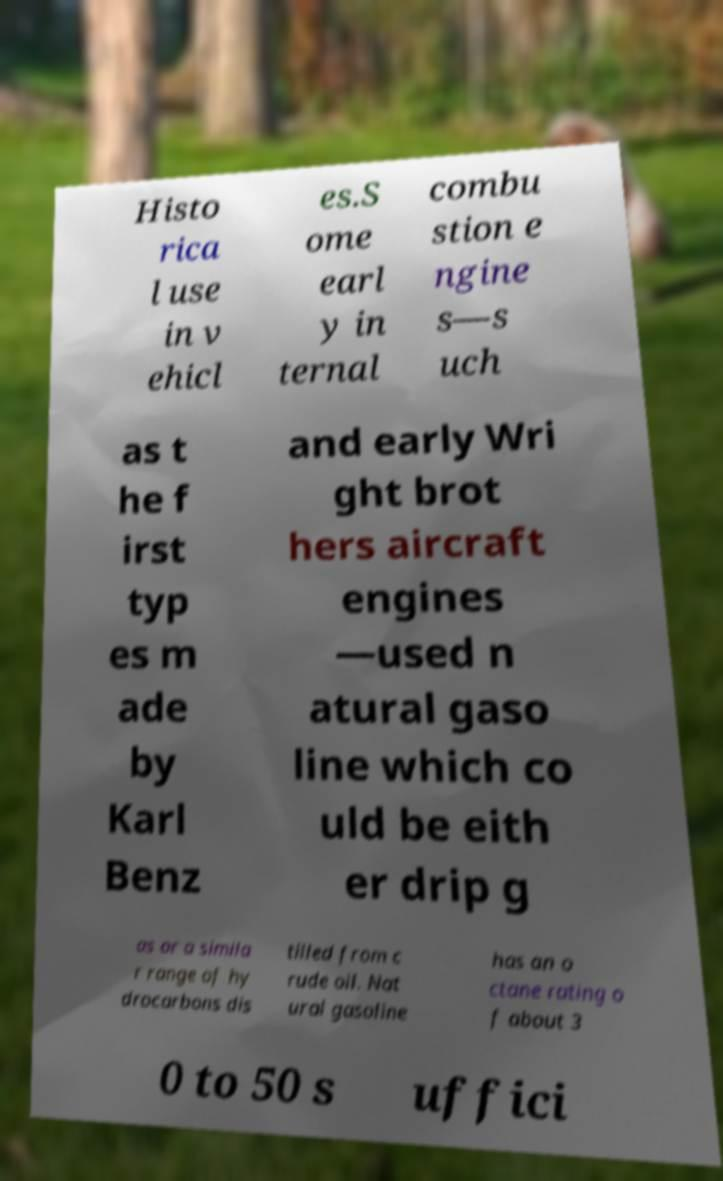Please identify and transcribe the text found in this image. Histo rica l use in v ehicl es.S ome earl y in ternal combu stion e ngine s—s uch as t he f irst typ es m ade by Karl Benz and early Wri ght brot hers aircraft engines —used n atural gaso line which co uld be eith er drip g as or a simila r range of hy drocarbons dis tilled from c rude oil. Nat ural gasoline has an o ctane rating o f about 3 0 to 50 s uffici 